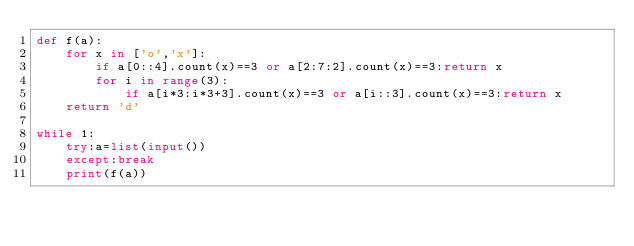<code> <loc_0><loc_0><loc_500><loc_500><_Python_>def f(a):
    for x in ['o','x']:
        if a[0::4].count(x)==3 or a[2:7:2].count(x)==3:return x
        for i in range(3):
            if a[i*3:i*3+3].count(x)==3 or a[i::3].count(x)==3:return x
    return 'd'

while 1:
    try:a=list(input())
    except:break
    print(f(a))</code> 